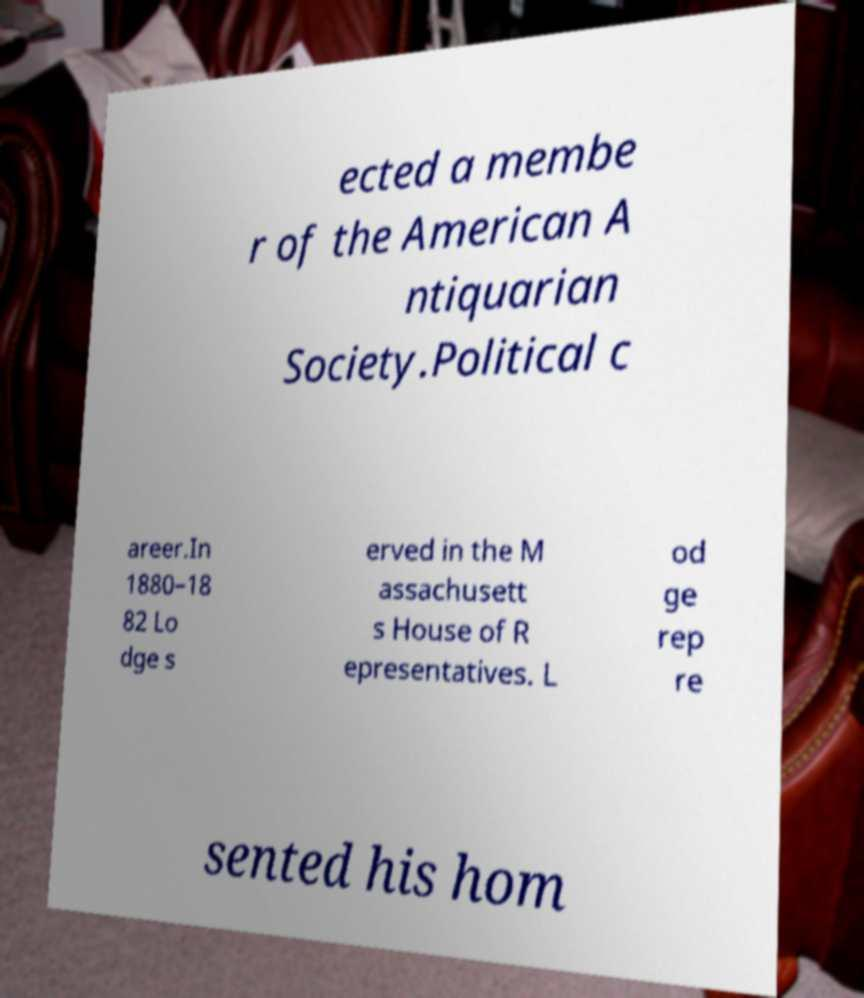Could you assist in decoding the text presented in this image and type it out clearly? ected a membe r of the American A ntiquarian Society.Political c areer.In 1880–18 82 Lo dge s erved in the M assachusett s House of R epresentatives. L od ge rep re sented his hom 